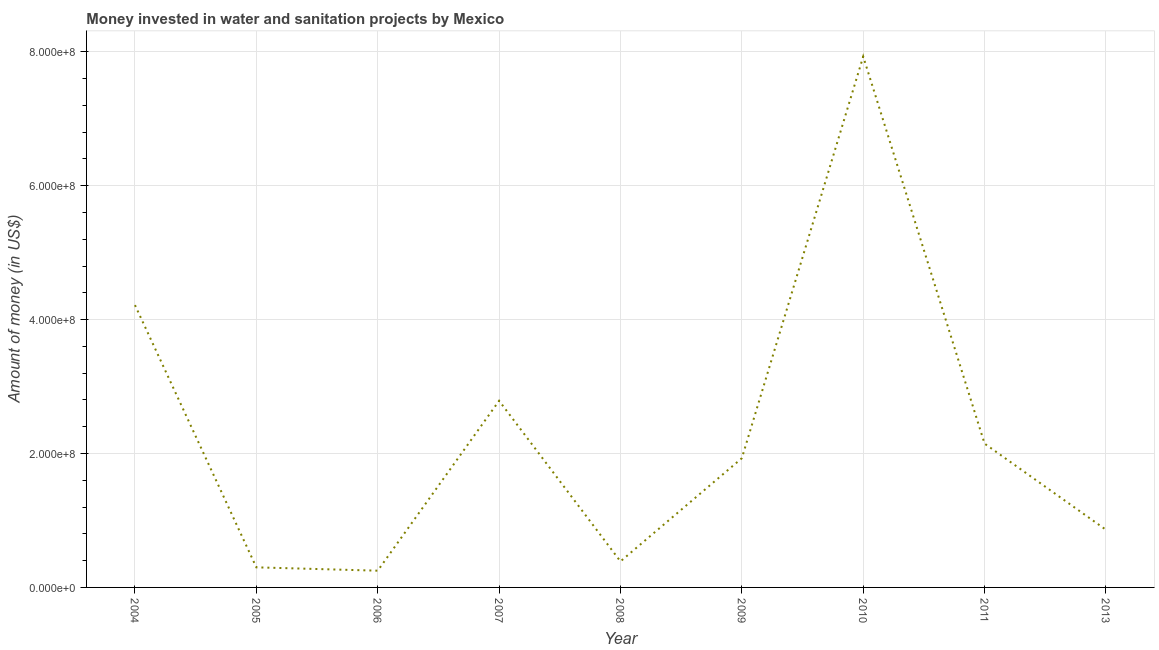What is the investment in 2006?
Provide a succinct answer. 2.50e+07. Across all years, what is the maximum investment?
Make the answer very short. 7.93e+08. Across all years, what is the minimum investment?
Offer a terse response. 2.50e+07. In which year was the investment minimum?
Your answer should be very brief. 2006. What is the sum of the investment?
Your response must be concise. 2.08e+09. What is the difference between the investment in 2007 and 2008?
Provide a short and direct response. 2.40e+08. What is the average investment per year?
Give a very brief answer. 2.31e+08. What is the median investment?
Offer a very short reply. 1.93e+08. In how many years, is the investment greater than 160000000 US$?
Ensure brevity in your answer.  5. What is the ratio of the investment in 2007 to that in 2009?
Make the answer very short. 1.44. Is the investment in 2006 less than that in 2013?
Provide a succinct answer. Yes. What is the difference between the highest and the second highest investment?
Provide a short and direct response. 3.71e+08. Is the sum of the investment in 2008 and 2009 greater than the maximum investment across all years?
Your answer should be compact. No. What is the difference between the highest and the lowest investment?
Your response must be concise. 7.68e+08. In how many years, is the investment greater than the average investment taken over all years?
Provide a succinct answer. 3. Does the investment monotonically increase over the years?
Ensure brevity in your answer.  No. How many lines are there?
Your answer should be compact. 1. What is the difference between two consecutive major ticks on the Y-axis?
Offer a very short reply. 2.00e+08. Does the graph contain any zero values?
Provide a short and direct response. No. Does the graph contain grids?
Give a very brief answer. Yes. What is the title of the graph?
Keep it short and to the point. Money invested in water and sanitation projects by Mexico. What is the label or title of the X-axis?
Make the answer very short. Year. What is the label or title of the Y-axis?
Give a very brief answer. Amount of money (in US$). What is the Amount of money (in US$) in 2004?
Provide a succinct answer. 4.22e+08. What is the Amount of money (in US$) in 2005?
Provide a short and direct response. 3.00e+07. What is the Amount of money (in US$) of 2006?
Your response must be concise. 2.50e+07. What is the Amount of money (in US$) of 2007?
Your response must be concise. 2.79e+08. What is the Amount of money (in US$) in 2008?
Offer a terse response. 3.89e+07. What is the Amount of money (in US$) of 2009?
Your answer should be very brief. 1.93e+08. What is the Amount of money (in US$) in 2010?
Offer a very short reply. 7.93e+08. What is the Amount of money (in US$) in 2011?
Your response must be concise. 2.15e+08. What is the Amount of money (in US$) of 2013?
Make the answer very short. 8.62e+07. What is the difference between the Amount of money (in US$) in 2004 and 2005?
Keep it short and to the point. 3.92e+08. What is the difference between the Amount of money (in US$) in 2004 and 2006?
Ensure brevity in your answer.  3.97e+08. What is the difference between the Amount of money (in US$) in 2004 and 2007?
Provide a short and direct response. 1.43e+08. What is the difference between the Amount of money (in US$) in 2004 and 2008?
Your answer should be compact. 3.83e+08. What is the difference between the Amount of money (in US$) in 2004 and 2009?
Give a very brief answer. 2.29e+08. What is the difference between the Amount of money (in US$) in 2004 and 2010?
Your answer should be very brief. -3.71e+08. What is the difference between the Amount of money (in US$) in 2004 and 2011?
Give a very brief answer. 2.07e+08. What is the difference between the Amount of money (in US$) in 2004 and 2013?
Provide a short and direct response. 3.36e+08. What is the difference between the Amount of money (in US$) in 2005 and 2007?
Keep it short and to the point. -2.49e+08. What is the difference between the Amount of money (in US$) in 2005 and 2008?
Your response must be concise. -8.90e+06. What is the difference between the Amount of money (in US$) in 2005 and 2009?
Offer a very short reply. -1.63e+08. What is the difference between the Amount of money (in US$) in 2005 and 2010?
Offer a terse response. -7.63e+08. What is the difference between the Amount of money (in US$) in 2005 and 2011?
Keep it short and to the point. -1.85e+08. What is the difference between the Amount of money (in US$) in 2005 and 2013?
Provide a succinct answer. -5.62e+07. What is the difference between the Amount of money (in US$) in 2006 and 2007?
Make the answer very short. -2.54e+08. What is the difference between the Amount of money (in US$) in 2006 and 2008?
Your response must be concise. -1.39e+07. What is the difference between the Amount of money (in US$) in 2006 and 2009?
Your response must be concise. -1.68e+08. What is the difference between the Amount of money (in US$) in 2006 and 2010?
Keep it short and to the point. -7.68e+08. What is the difference between the Amount of money (in US$) in 2006 and 2011?
Make the answer very short. -1.90e+08. What is the difference between the Amount of money (in US$) in 2006 and 2013?
Offer a very short reply. -6.12e+07. What is the difference between the Amount of money (in US$) in 2007 and 2008?
Ensure brevity in your answer.  2.40e+08. What is the difference between the Amount of money (in US$) in 2007 and 2009?
Give a very brief answer. 8.58e+07. What is the difference between the Amount of money (in US$) in 2007 and 2010?
Your response must be concise. -5.14e+08. What is the difference between the Amount of money (in US$) in 2007 and 2011?
Keep it short and to the point. 6.40e+07. What is the difference between the Amount of money (in US$) in 2007 and 2013?
Provide a succinct answer. 1.93e+08. What is the difference between the Amount of money (in US$) in 2008 and 2009?
Your answer should be very brief. -1.54e+08. What is the difference between the Amount of money (in US$) in 2008 and 2010?
Offer a very short reply. -7.54e+08. What is the difference between the Amount of money (in US$) in 2008 and 2011?
Offer a very short reply. -1.76e+08. What is the difference between the Amount of money (in US$) in 2008 and 2013?
Offer a very short reply. -4.72e+07. What is the difference between the Amount of money (in US$) in 2009 and 2010?
Give a very brief answer. -6.00e+08. What is the difference between the Amount of money (in US$) in 2009 and 2011?
Your response must be concise. -2.18e+07. What is the difference between the Amount of money (in US$) in 2009 and 2013?
Make the answer very short. 1.07e+08. What is the difference between the Amount of money (in US$) in 2010 and 2011?
Provide a succinct answer. 5.78e+08. What is the difference between the Amount of money (in US$) in 2010 and 2013?
Provide a succinct answer. 7.07e+08. What is the difference between the Amount of money (in US$) in 2011 and 2013?
Your answer should be compact. 1.29e+08. What is the ratio of the Amount of money (in US$) in 2004 to that in 2005?
Make the answer very short. 14.06. What is the ratio of the Amount of money (in US$) in 2004 to that in 2006?
Offer a very short reply. 16.87. What is the ratio of the Amount of money (in US$) in 2004 to that in 2007?
Keep it short and to the point. 1.51. What is the ratio of the Amount of money (in US$) in 2004 to that in 2008?
Your answer should be very brief. 10.84. What is the ratio of the Amount of money (in US$) in 2004 to that in 2009?
Keep it short and to the point. 2.19. What is the ratio of the Amount of money (in US$) in 2004 to that in 2010?
Provide a succinct answer. 0.53. What is the ratio of the Amount of money (in US$) in 2004 to that in 2011?
Offer a terse response. 1.96. What is the ratio of the Amount of money (in US$) in 2004 to that in 2013?
Your answer should be compact. 4.89. What is the ratio of the Amount of money (in US$) in 2005 to that in 2006?
Keep it short and to the point. 1.2. What is the ratio of the Amount of money (in US$) in 2005 to that in 2007?
Ensure brevity in your answer.  0.11. What is the ratio of the Amount of money (in US$) in 2005 to that in 2008?
Offer a very short reply. 0.77. What is the ratio of the Amount of money (in US$) in 2005 to that in 2009?
Offer a very short reply. 0.15. What is the ratio of the Amount of money (in US$) in 2005 to that in 2010?
Offer a very short reply. 0.04. What is the ratio of the Amount of money (in US$) in 2005 to that in 2011?
Your response must be concise. 0.14. What is the ratio of the Amount of money (in US$) in 2005 to that in 2013?
Your response must be concise. 0.35. What is the ratio of the Amount of money (in US$) in 2006 to that in 2007?
Provide a succinct answer. 0.09. What is the ratio of the Amount of money (in US$) in 2006 to that in 2008?
Provide a short and direct response. 0.64. What is the ratio of the Amount of money (in US$) in 2006 to that in 2009?
Provide a succinct answer. 0.13. What is the ratio of the Amount of money (in US$) in 2006 to that in 2010?
Keep it short and to the point. 0.03. What is the ratio of the Amount of money (in US$) in 2006 to that in 2011?
Make the answer very short. 0.12. What is the ratio of the Amount of money (in US$) in 2006 to that in 2013?
Provide a short and direct response. 0.29. What is the ratio of the Amount of money (in US$) in 2007 to that in 2008?
Your answer should be compact. 7.17. What is the ratio of the Amount of money (in US$) in 2007 to that in 2009?
Your answer should be very brief. 1.45. What is the ratio of the Amount of money (in US$) in 2007 to that in 2010?
Give a very brief answer. 0.35. What is the ratio of the Amount of money (in US$) in 2007 to that in 2011?
Offer a terse response. 1.3. What is the ratio of the Amount of money (in US$) in 2007 to that in 2013?
Make the answer very short. 3.24. What is the ratio of the Amount of money (in US$) in 2008 to that in 2009?
Your answer should be very brief. 0.2. What is the ratio of the Amount of money (in US$) in 2008 to that in 2010?
Keep it short and to the point. 0.05. What is the ratio of the Amount of money (in US$) in 2008 to that in 2011?
Keep it short and to the point. 0.18. What is the ratio of the Amount of money (in US$) in 2008 to that in 2013?
Your answer should be very brief. 0.45. What is the ratio of the Amount of money (in US$) in 2009 to that in 2010?
Your answer should be compact. 0.24. What is the ratio of the Amount of money (in US$) in 2009 to that in 2011?
Give a very brief answer. 0.9. What is the ratio of the Amount of money (in US$) in 2009 to that in 2013?
Ensure brevity in your answer.  2.24. What is the ratio of the Amount of money (in US$) in 2010 to that in 2011?
Make the answer very short. 3.69. What is the ratio of the Amount of money (in US$) in 2010 to that in 2013?
Your answer should be compact. 9.21. What is the ratio of the Amount of money (in US$) in 2011 to that in 2013?
Ensure brevity in your answer.  2.49. 